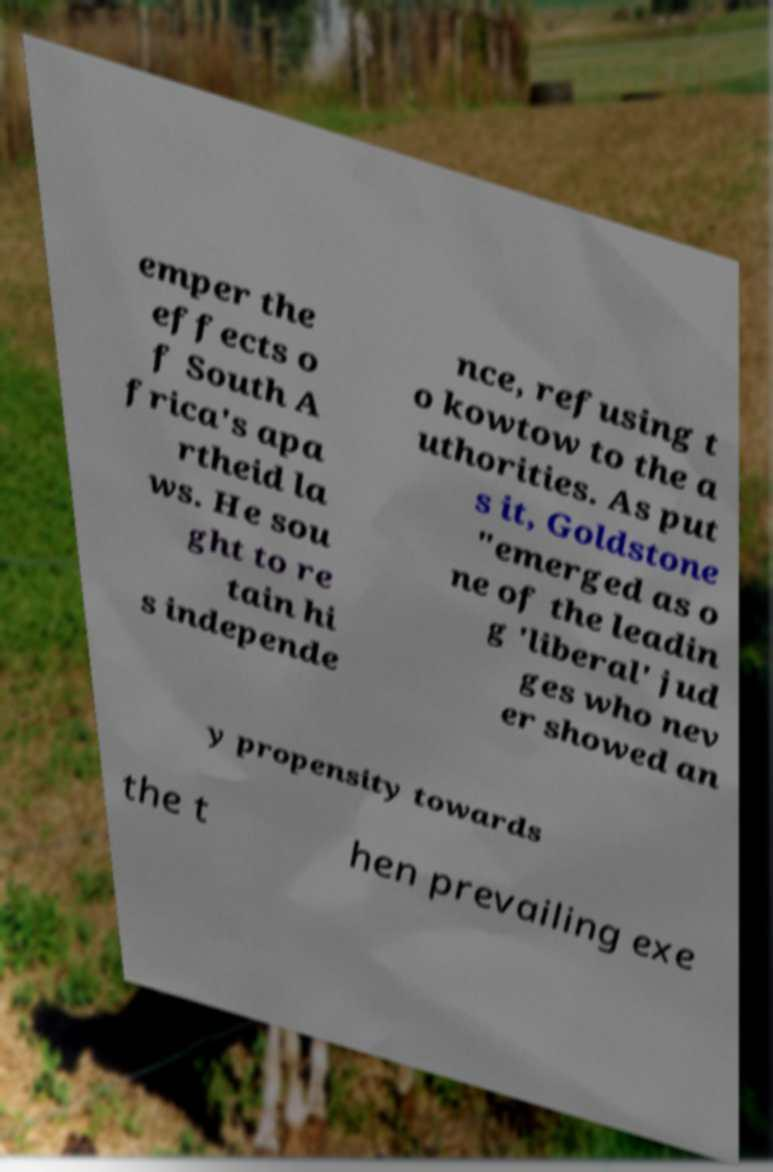For documentation purposes, I need the text within this image transcribed. Could you provide that? emper the effects o f South A frica's apa rtheid la ws. He sou ght to re tain hi s independe nce, refusing t o kowtow to the a uthorities. As put s it, Goldstone "emerged as o ne of the leadin g 'liberal' jud ges who nev er showed an y propensity towards the t hen prevailing exe 